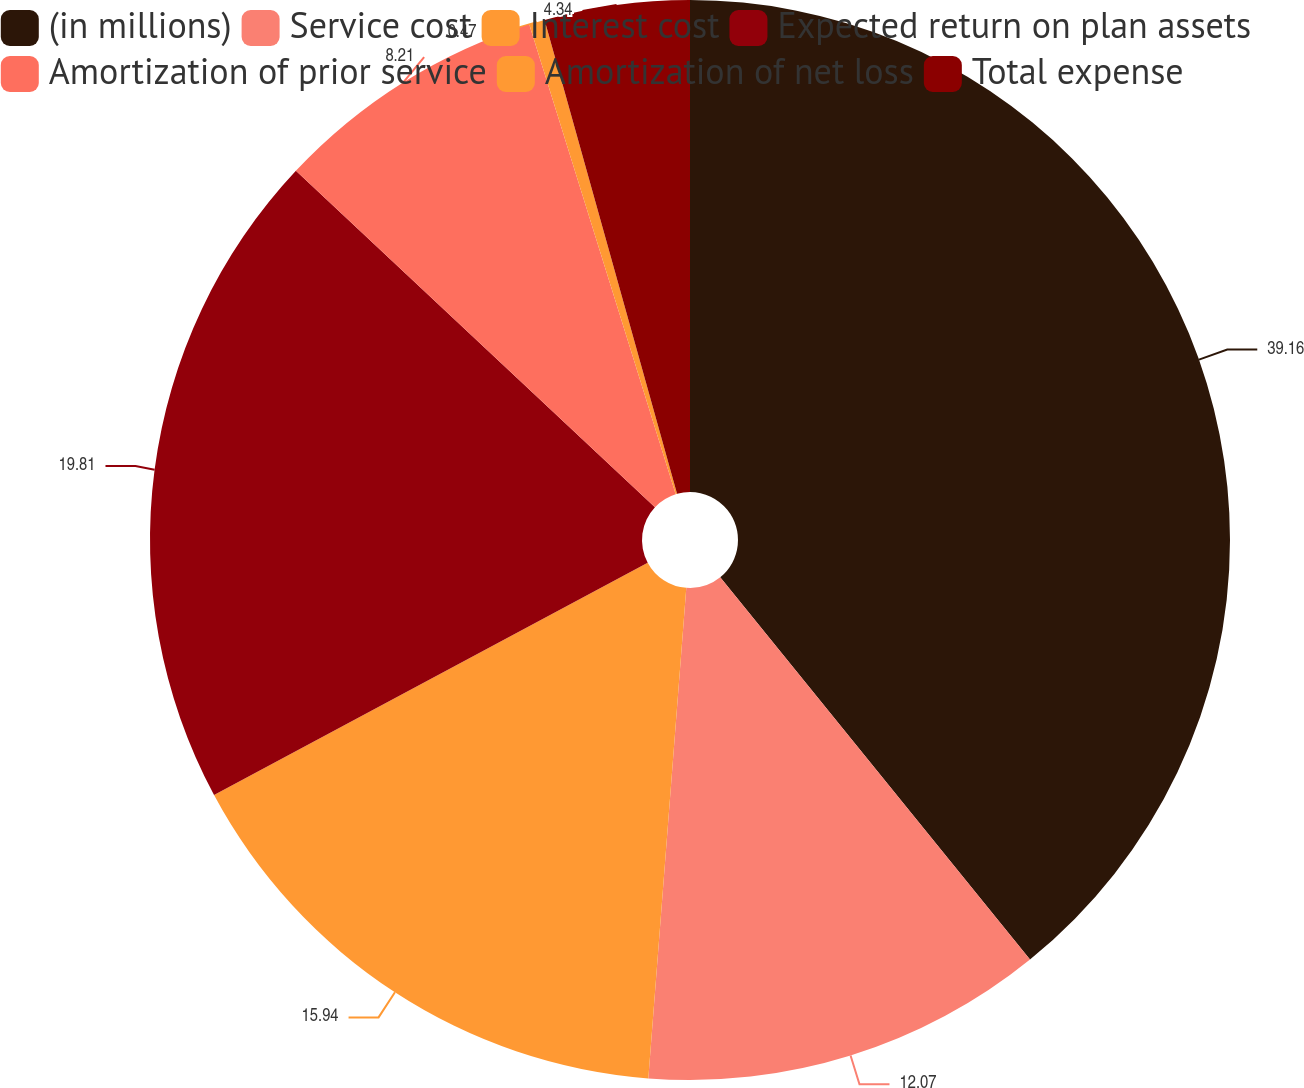Convert chart to OTSL. <chart><loc_0><loc_0><loc_500><loc_500><pie_chart><fcel>(in millions)<fcel>Service cost<fcel>Interest cost<fcel>Expected return on plan assets<fcel>Amortization of prior service<fcel>Amortization of net loss<fcel>Total expense<nl><fcel>39.16%<fcel>12.07%<fcel>15.94%<fcel>19.81%<fcel>8.21%<fcel>0.47%<fcel>4.34%<nl></chart> 